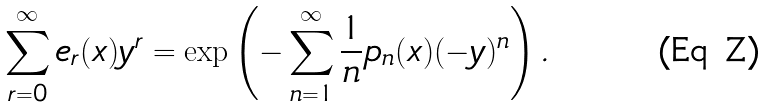<formula> <loc_0><loc_0><loc_500><loc_500>\sum _ { r = 0 } ^ { \infty } e _ { r } ( x ) y ^ { r } = \exp \left ( - \sum _ { n = 1 } ^ { \infty } \frac { 1 } { n } p _ { n } ( x ) ( - y ) ^ { n } \right ) .</formula> 